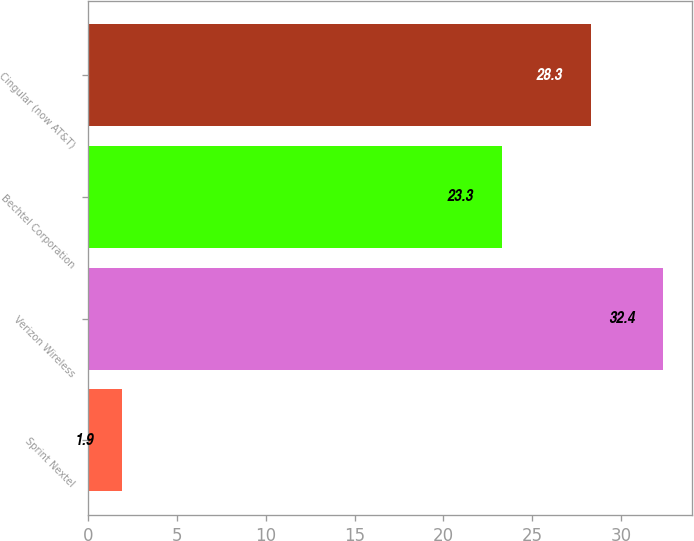<chart> <loc_0><loc_0><loc_500><loc_500><bar_chart><fcel>Sprint Nextel<fcel>Verizon Wireless<fcel>Bechtel Corporation<fcel>Cingular (now AT&T)<nl><fcel>1.9<fcel>32.4<fcel>23.3<fcel>28.3<nl></chart> 